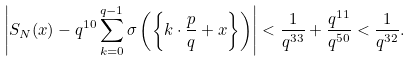Convert formula to latex. <formula><loc_0><loc_0><loc_500><loc_500>\left | S _ { N } ( x ) - q ^ { 1 0 } \sum _ { k = 0 } ^ { q - 1 } \sigma \left ( \left \{ k \cdot \frac { p } { q } + x \right \} \right ) \right | < \frac { 1 } { q ^ { 3 3 } } + \frac { q ^ { 1 1 } } { q ^ { 5 0 } } < \frac { 1 } { q ^ { 3 2 } } .</formula> 